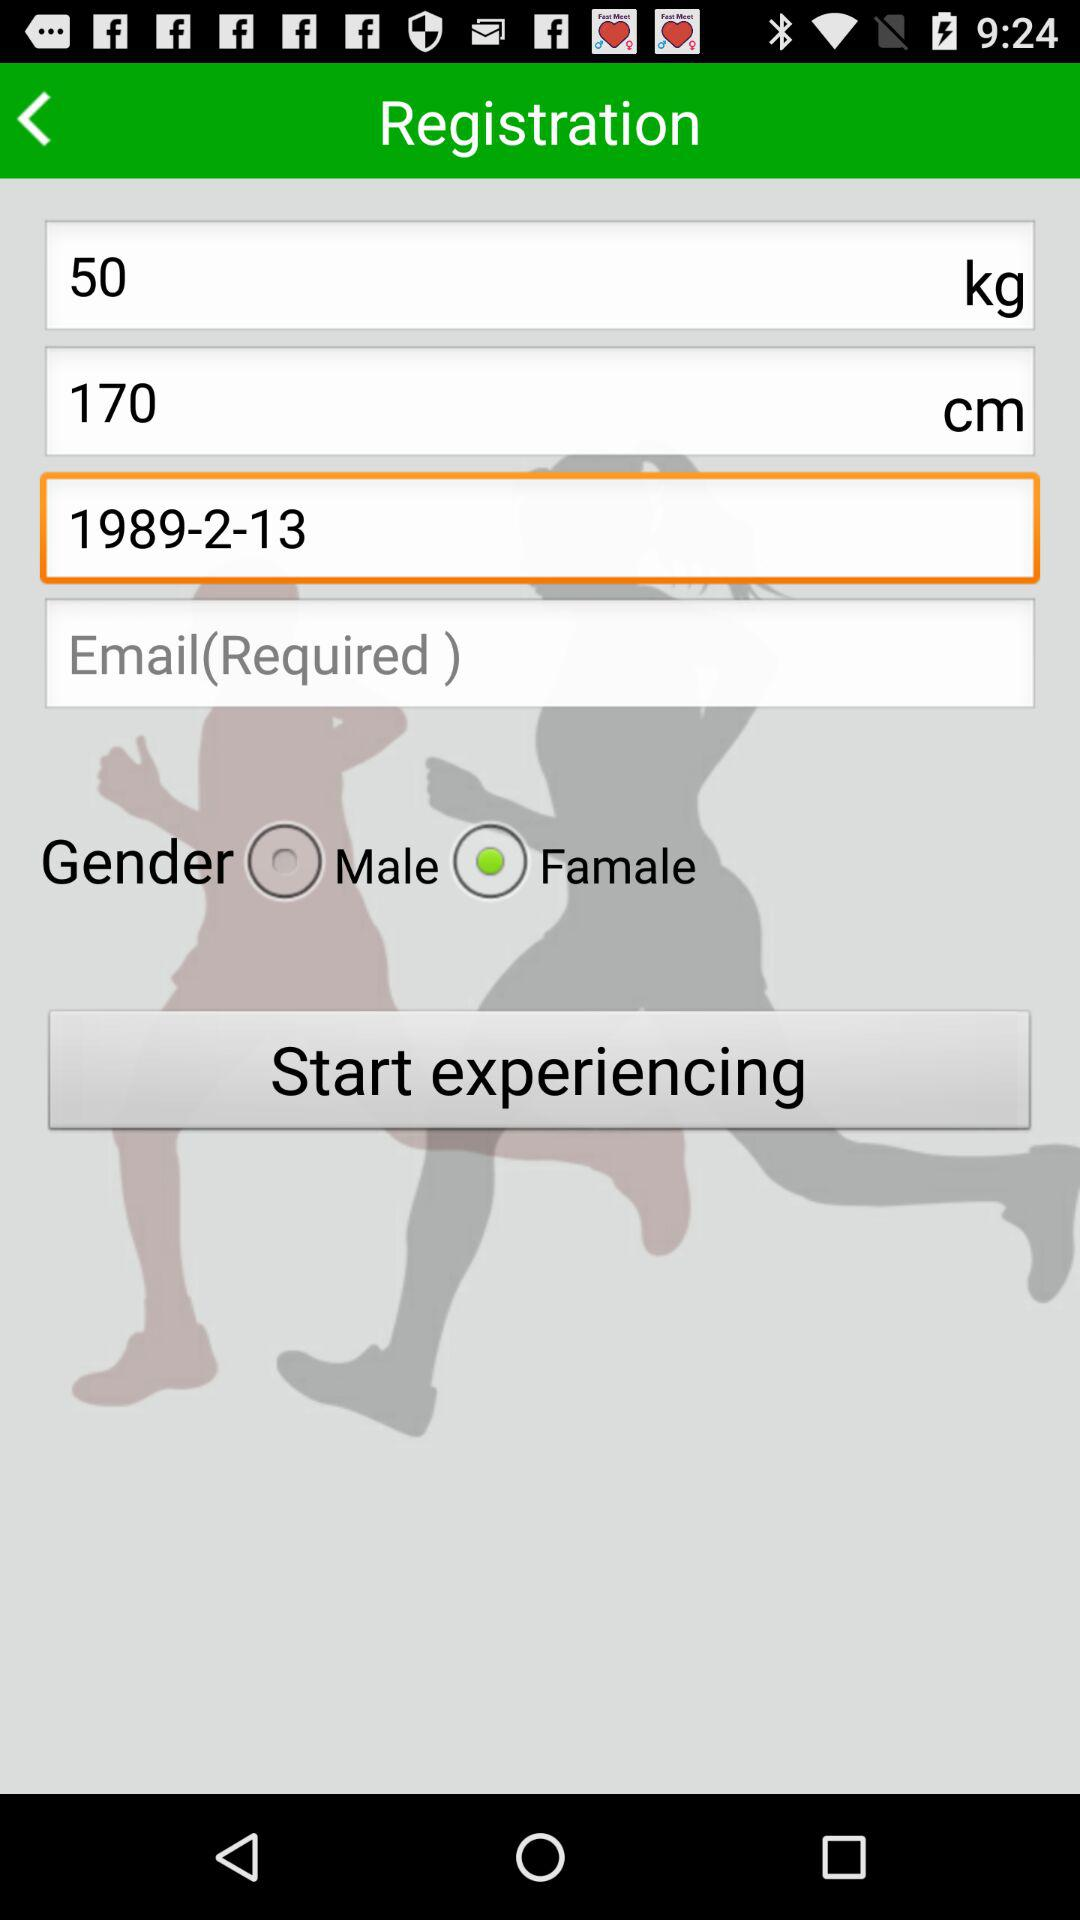What is the selected gender? The selected gender is "Famale". 